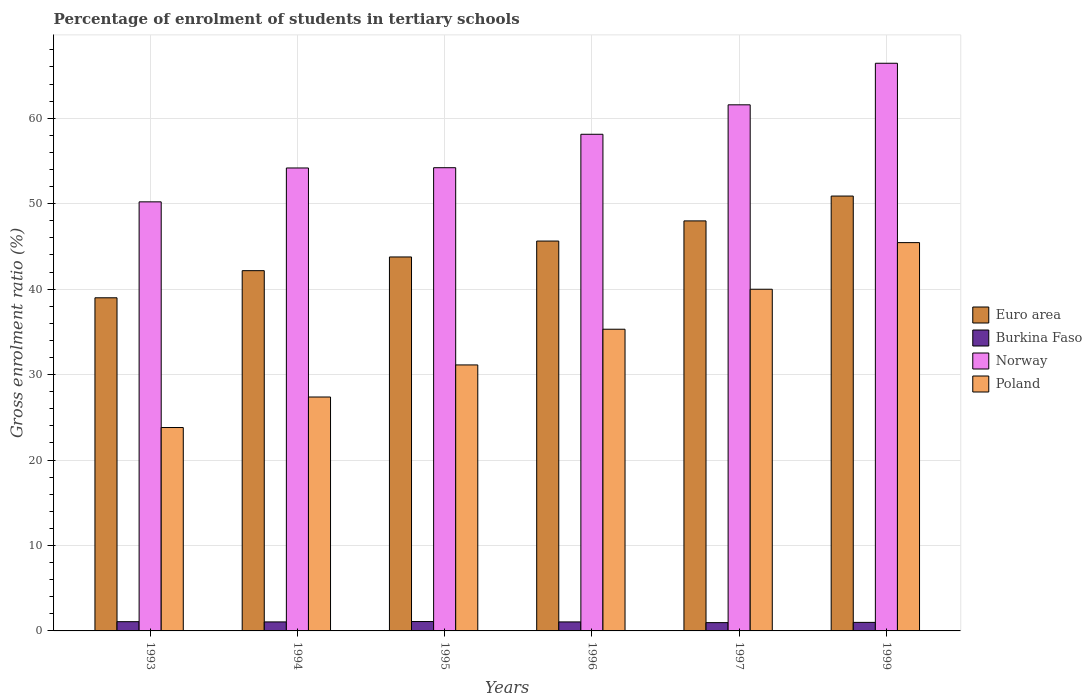Are the number of bars per tick equal to the number of legend labels?
Offer a very short reply. Yes. Are the number of bars on each tick of the X-axis equal?
Ensure brevity in your answer.  Yes. How many bars are there on the 3rd tick from the right?
Make the answer very short. 4. What is the label of the 3rd group of bars from the left?
Your response must be concise. 1995. What is the percentage of students enrolled in tertiary schools in Poland in 1995?
Your answer should be very brief. 31.13. Across all years, what is the maximum percentage of students enrolled in tertiary schools in Euro area?
Keep it short and to the point. 50.89. Across all years, what is the minimum percentage of students enrolled in tertiary schools in Norway?
Your response must be concise. 50.21. What is the total percentage of students enrolled in tertiary schools in Norway in the graph?
Give a very brief answer. 344.69. What is the difference between the percentage of students enrolled in tertiary schools in Euro area in 1997 and that in 1999?
Provide a succinct answer. -2.91. What is the difference between the percentage of students enrolled in tertiary schools in Burkina Faso in 1993 and the percentage of students enrolled in tertiary schools in Poland in 1995?
Give a very brief answer. -30.04. What is the average percentage of students enrolled in tertiary schools in Poland per year?
Offer a very short reply. 33.84. In the year 1996, what is the difference between the percentage of students enrolled in tertiary schools in Poland and percentage of students enrolled in tertiary schools in Burkina Faso?
Your answer should be very brief. 34.25. What is the ratio of the percentage of students enrolled in tertiary schools in Poland in 1994 to that in 1995?
Your response must be concise. 0.88. Is the percentage of students enrolled in tertiary schools in Norway in 1996 less than that in 1997?
Keep it short and to the point. Yes. Is the difference between the percentage of students enrolled in tertiary schools in Poland in 1994 and 1997 greater than the difference between the percentage of students enrolled in tertiary schools in Burkina Faso in 1994 and 1997?
Your answer should be very brief. No. What is the difference between the highest and the second highest percentage of students enrolled in tertiary schools in Burkina Faso?
Make the answer very short. 0.02. What is the difference between the highest and the lowest percentage of students enrolled in tertiary schools in Poland?
Your answer should be very brief. 21.64. Is it the case that in every year, the sum of the percentage of students enrolled in tertiary schools in Burkina Faso and percentage of students enrolled in tertiary schools in Norway is greater than the sum of percentage of students enrolled in tertiary schools in Poland and percentage of students enrolled in tertiary schools in Euro area?
Your answer should be very brief. Yes. What does the 3rd bar from the left in 1996 represents?
Your answer should be very brief. Norway. How many bars are there?
Your answer should be very brief. 24. Are all the bars in the graph horizontal?
Offer a very short reply. No. What is the difference between two consecutive major ticks on the Y-axis?
Your response must be concise. 10. Are the values on the major ticks of Y-axis written in scientific E-notation?
Provide a short and direct response. No. Does the graph contain grids?
Provide a short and direct response. Yes. Where does the legend appear in the graph?
Ensure brevity in your answer.  Center right. How are the legend labels stacked?
Offer a terse response. Vertical. What is the title of the graph?
Your response must be concise. Percentage of enrolment of students in tertiary schools. Does "Albania" appear as one of the legend labels in the graph?
Provide a succinct answer. No. What is the label or title of the Y-axis?
Your answer should be compact. Gross enrolment ratio (%). What is the Gross enrolment ratio (%) in Euro area in 1993?
Ensure brevity in your answer.  38.98. What is the Gross enrolment ratio (%) in Burkina Faso in 1993?
Offer a terse response. 1.08. What is the Gross enrolment ratio (%) in Norway in 1993?
Your answer should be very brief. 50.21. What is the Gross enrolment ratio (%) of Poland in 1993?
Your answer should be compact. 23.8. What is the Gross enrolment ratio (%) in Euro area in 1994?
Your response must be concise. 42.16. What is the Gross enrolment ratio (%) of Burkina Faso in 1994?
Offer a very short reply. 1.05. What is the Gross enrolment ratio (%) of Norway in 1994?
Keep it short and to the point. 54.17. What is the Gross enrolment ratio (%) of Poland in 1994?
Make the answer very short. 27.37. What is the Gross enrolment ratio (%) in Euro area in 1995?
Your response must be concise. 43.76. What is the Gross enrolment ratio (%) in Burkina Faso in 1995?
Make the answer very short. 1.1. What is the Gross enrolment ratio (%) of Norway in 1995?
Offer a very short reply. 54.2. What is the Gross enrolment ratio (%) of Poland in 1995?
Make the answer very short. 31.13. What is the Gross enrolment ratio (%) of Euro area in 1996?
Your answer should be very brief. 45.62. What is the Gross enrolment ratio (%) of Burkina Faso in 1996?
Offer a terse response. 1.05. What is the Gross enrolment ratio (%) in Norway in 1996?
Ensure brevity in your answer.  58.12. What is the Gross enrolment ratio (%) in Poland in 1996?
Your answer should be very brief. 35.3. What is the Gross enrolment ratio (%) in Euro area in 1997?
Your response must be concise. 47.98. What is the Gross enrolment ratio (%) in Burkina Faso in 1997?
Your answer should be compact. 0.97. What is the Gross enrolment ratio (%) of Norway in 1997?
Your answer should be very brief. 61.56. What is the Gross enrolment ratio (%) in Poland in 1997?
Offer a very short reply. 39.98. What is the Gross enrolment ratio (%) of Euro area in 1999?
Offer a very short reply. 50.89. What is the Gross enrolment ratio (%) of Burkina Faso in 1999?
Make the answer very short. 1. What is the Gross enrolment ratio (%) in Norway in 1999?
Your answer should be very brief. 66.43. What is the Gross enrolment ratio (%) in Poland in 1999?
Your answer should be compact. 45.44. Across all years, what is the maximum Gross enrolment ratio (%) in Euro area?
Your answer should be very brief. 50.89. Across all years, what is the maximum Gross enrolment ratio (%) in Burkina Faso?
Ensure brevity in your answer.  1.1. Across all years, what is the maximum Gross enrolment ratio (%) of Norway?
Your response must be concise. 66.43. Across all years, what is the maximum Gross enrolment ratio (%) of Poland?
Provide a succinct answer. 45.44. Across all years, what is the minimum Gross enrolment ratio (%) of Euro area?
Provide a succinct answer. 38.98. Across all years, what is the minimum Gross enrolment ratio (%) of Burkina Faso?
Ensure brevity in your answer.  0.97. Across all years, what is the minimum Gross enrolment ratio (%) in Norway?
Your answer should be very brief. 50.21. Across all years, what is the minimum Gross enrolment ratio (%) in Poland?
Make the answer very short. 23.8. What is the total Gross enrolment ratio (%) in Euro area in the graph?
Your response must be concise. 269.39. What is the total Gross enrolment ratio (%) in Burkina Faso in the graph?
Keep it short and to the point. 6.26. What is the total Gross enrolment ratio (%) in Norway in the graph?
Offer a terse response. 344.69. What is the total Gross enrolment ratio (%) in Poland in the graph?
Keep it short and to the point. 203.02. What is the difference between the Gross enrolment ratio (%) in Euro area in 1993 and that in 1994?
Provide a succinct answer. -3.17. What is the difference between the Gross enrolment ratio (%) in Burkina Faso in 1993 and that in 1994?
Give a very brief answer. 0.03. What is the difference between the Gross enrolment ratio (%) in Norway in 1993 and that in 1994?
Provide a succinct answer. -3.96. What is the difference between the Gross enrolment ratio (%) in Poland in 1993 and that in 1994?
Give a very brief answer. -3.57. What is the difference between the Gross enrolment ratio (%) in Euro area in 1993 and that in 1995?
Provide a succinct answer. -4.78. What is the difference between the Gross enrolment ratio (%) of Burkina Faso in 1993 and that in 1995?
Offer a terse response. -0.02. What is the difference between the Gross enrolment ratio (%) in Norway in 1993 and that in 1995?
Provide a short and direct response. -4. What is the difference between the Gross enrolment ratio (%) in Poland in 1993 and that in 1995?
Your answer should be compact. -7.32. What is the difference between the Gross enrolment ratio (%) in Euro area in 1993 and that in 1996?
Offer a terse response. -6.64. What is the difference between the Gross enrolment ratio (%) in Burkina Faso in 1993 and that in 1996?
Your answer should be compact. 0.03. What is the difference between the Gross enrolment ratio (%) in Norway in 1993 and that in 1996?
Ensure brevity in your answer.  -7.91. What is the difference between the Gross enrolment ratio (%) in Poland in 1993 and that in 1996?
Your response must be concise. -11.5. What is the difference between the Gross enrolment ratio (%) in Euro area in 1993 and that in 1997?
Offer a very short reply. -9. What is the difference between the Gross enrolment ratio (%) of Burkina Faso in 1993 and that in 1997?
Make the answer very short. 0.11. What is the difference between the Gross enrolment ratio (%) in Norway in 1993 and that in 1997?
Your answer should be compact. -11.36. What is the difference between the Gross enrolment ratio (%) of Poland in 1993 and that in 1997?
Your response must be concise. -16.18. What is the difference between the Gross enrolment ratio (%) in Euro area in 1993 and that in 1999?
Give a very brief answer. -11.9. What is the difference between the Gross enrolment ratio (%) in Burkina Faso in 1993 and that in 1999?
Provide a short and direct response. 0.08. What is the difference between the Gross enrolment ratio (%) of Norway in 1993 and that in 1999?
Give a very brief answer. -16.22. What is the difference between the Gross enrolment ratio (%) in Poland in 1993 and that in 1999?
Ensure brevity in your answer.  -21.64. What is the difference between the Gross enrolment ratio (%) of Euro area in 1994 and that in 1995?
Offer a very short reply. -1.6. What is the difference between the Gross enrolment ratio (%) of Burkina Faso in 1994 and that in 1995?
Your response must be concise. -0.04. What is the difference between the Gross enrolment ratio (%) of Norway in 1994 and that in 1995?
Give a very brief answer. -0.03. What is the difference between the Gross enrolment ratio (%) in Poland in 1994 and that in 1995?
Your answer should be very brief. -3.75. What is the difference between the Gross enrolment ratio (%) of Euro area in 1994 and that in 1996?
Provide a short and direct response. -3.46. What is the difference between the Gross enrolment ratio (%) in Norway in 1994 and that in 1996?
Make the answer very short. -3.94. What is the difference between the Gross enrolment ratio (%) of Poland in 1994 and that in 1996?
Offer a terse response. -7.93. What is the difference between the Gross enrolment ratio (%) of Euro area in 1994 and that in 1997?
Keep it short and to the point. -5.82. What is the difference between the Gross enrolment ratio (%) of Burkina Faso in 1994 and that in 1997?
Provide a short and direct response. 0.09. What is the difference between the Gross enrolment ratio (%) in Norway in 1994 and that in 1997?
Keep it short and to the point. -7.39. What is the difference between the Gross enrolment ratio (%) of Poland in 1994 and that in 1997?
Keep it short and to the point. -12.61. What is the difference between the Gross enrolment ratio (%) in Euro area in 1994 and that in 1999?
Provide a short and direct response. -8.73. What is the difference between the Gross enrolment ratio (%) in Burkina Faso in 1994 and that in 1999?
Ensure brevity in your answer.  0.06. What is the difference between the Gross enrolment ratio (%) in Norway in 1994 and that in 1999?
Give a very brief answer. -12.25. What is the difference between the Gross enrolment ratio (%) in Poland in 1994 and that in 1999?
Your answer should be compact. -18.07. What is the difference between the Gross enrolment ratio (%) of Euro area in 1995 and that in 1996?
Offer a very short reply. -1.86. What is the difference between the Gross enrolment ratio (%) of Burkina Faso in 1995 and that in 1996?
Provide a succinct answer. 0.04. What is the difference between the Gross enrolment ratio (%) of Norway in 1995 and that in 1996?
Your response must be concise. -3.91. What is the difference between the Gross enrolment ratio (%) in Poland in 1995 and that in 1996?
Provide a succinct answer. -4.18. What is the difference between the Gross enrolment ratio (%) of Euro area in 1995 and that in 1997?
Give a very brief answer. -4.22. What is the difference between the Gross enrolment ratio (%) in Burkina Faso in 1995 and that in 1997?
Keep it short and to the point. 0.13. What is the difference between the Gross enrolment ratio (%) of Norway in 1995 and that in 1997?
Keep it short and to the point. -7.36. What is the difference between the Gross enrolment ratio (%) in Poland in 1995 and that in 1997?
Ensure brevity in your answer.  -8.86. What is the difference between the Gross enrolment ratio (%) in Euro area in 1995 and that in 1999?
Provide a succinct answer. -7.13. What is the difference between the Gross enrolment ratio (%) in Burkina Faso in 1995 and that in 1999?
Offer a terse response. 0.1. What is the difference between the Gross enrolment ratio (%) in Norway in 1995 and that in 1999?
Keep it short and to the point. -12.22. What is the difference between the Gross enrolment ratio (%) of Poland in 1995 and that in 1999?
Your answer should be compact. -14.31. What is the difference between the Gross enrolment ratio (%) in Euro area in 1996 and that in 1997?
Provide a short and direct response. -2.36. What is the difference between the Gross enrolment ratio (%) in Burkina Faso in 1996 and that in 1997?
Offer a terse response. 0.09. What is the difference between the Gross enrolment ratio (%) of Norway in 1996 and that in 1997?
Offer a very short reply. -3.45. What is the difference between the Gross enrolment ratio (%) of Poland in 1996 and that in 1997?
Offer a very short reply. -4.68. What is the difference between the Gross enrolment ratio (%) in Euro area in 1996 and that in 1999?
Your answer should be very brief. -5.27. What is the difference between the Gross enrolment ratio (%) in Burkina Faso in 1996 and that in 1999?
Provide a succinct answer. 0.06. What is the difference between the Gross enrolment ratio (%) in Norway in 1996 and that in 1999?
Ensure brevity in your answer.  -8.31. What is the difference between the Gross enrolment ratio (%) of Poland in 1996 and that in 1999?
Your answer should be compact. -10.13. What is the difference between the Gross enrolment ratio (%) of Euro area in 1997 and that in 1999?
Ensure brevity in your answer.  -2.91. What is the difference between the Gross enrolment ratio (%) of Burkina Faso in 1997 and that in 1999?
Provide a succinct answer. -0.03. What is the difference between the Gross enrolment ratio (%) in Norway in 1997 and that in 1999?
Offer a very short reply. -4.86. What is the difference between the Gross enrolment ratio (%) in Poland in 1997 and that in 1999?
Offer a terse response. -5.46. What is the difference between the Gross enrolment ratio (%) of Euro area in 1993 and the Gross enrolment ratio (%) of Burkina Faso in 1994?
Your answer should be compact. 37.93. What is the difference between the Gross enrolment ratio (%) in Euro area in 1993 and the Gross enrolment ratio (%) in Norway in 1994?
Your response must be concise. -15.19. What is the difference between the Gross enrolment ratio (%) in Euro area in 1993 and the Gross enrolment ratio (%) in Poland in 1994?
Your answer should be compact. 11.61. What is the difference between the Gross enrolment ratio (%) in Burkina Faso in 1993 and the Gross enrolment ratio (%) in Norway in 1994?
Your answer should be compact. -53.09. What is the difference between the Gross enrolment ratio (%) in Burkina Faso in 1993 and the Gross enrolment ratio (%) in Poland in 1994?
Your answer should be compact. -26.29. What is the difference between the Gross enrolment ratio (%) in Norway in 1993 and the Gross enrolment ratio (%) in Poland in 1994?
Keep it short and to the point. 22.84. What is the difference between the Gross enrolment ratio (%) of Euro area in 1993 and the Gross enrolment ratio (%) of Burkina Faso in 1995?
Your answer should be compact. 37.88. What is the difference between the Gross enrolment ratio (%) of Euro area in 1993 and the Gross enrolment ratio (%) of Norway in 1995?
Offer a very short reply. -15.22. What is the difference between the Gross enrolment ratio (%) of Euro area in 1993 and the Gross enrolment ratio (%) of Poland in 1995?
Ensure brevity in your answer.  7.86. What is the difference between the Gross enrolment ratio (%) of Burkina Faso in 1993 and the Gross enrolment ratio (%) of Norway in 1995?
Your response must be concise. -53.12. What is the difference between the Gross enrolment ratio (%) of Burkina Faso in 1993 and the Gross enrolment ratio (%) of Poland in 1995?
Keep it short and to the point. -30.04. What is the difference between the Gross enrolment ratio (%) of Norway in 1993 and the Gross enrolment ratio (%) of Poland in 1995?
Provide a succinct answer. 19.08. What is the difference between the Gross enrolment ratio (%) in Euro area in 1993 and the Gross enrolment ratio (%) in Burkina Faso in 1996?
Give a very brief answer. 37.93. What is the difference between the Gross enrolment ratio (%) in Euro area in 1993 and the Gross enrolment ratio (%) in Norway in 1996?
Offer a terse response. -19.13. What is the difference between the Gross enrolment ratio (%) of Euro area in 1993 and the Gross enrolment ratio (%) of Poland in 1996?
Ensure brevity in your answer.  3.68. What is the difference between the Gross enrolment ratio (%) of Burkina Faso in 1993 and the Gross enrolment ratio (%) of Norway in 1996?
Provide a succinct answer. -57.04. What is the difference between the Gross enrolment ratio (%) in Burkina Faso in 1993 and the Gross enrolment ratio (%) in Poland in 1996?
Give a very brief answer. -34.22. What is the difference between the Gross enrolment ratio (%) of Norway in 1993 and the Gross enrolment ratio (%) of Poland in 1996?
Keep it short and to the point. 14.9. What is the difference between the Gross enrolment ratio (%) of Euro area in 1993 and the Gross enrolment ratio (%) of Burkina Faso in 1997?
Offer a very short reply. 38.01. What is the difference between the Gross enrolment ratio (%) of Euro area in 1993 and the Gross enrolment ratio (%) of Norway in 1997?
Give a very brief answer. -22.58. What is the difference between the Gross enrolment ratio (%) of Euro area in 1993 and the Gross enrolment ratio (%) of Poland in 1997?
Ensure brevity in your answer.  -1. What is the difference between the Gross enrolment ratio (%) of Burkina Faso in 1993 and the Gross enrolment ratio (%) of Norway in 1997?
Offer a very short reply. -60.48. What is the difference between the Gross enrolment ratio (%) in Burkina Faso in 1993 and the Gross enrolment ratio (%) in Poland in 1997?
Keep it short and to the point. -38.9. What is the difference between the Gross enrolment ratio (%) of Norway in 1993 and the Gross enrolment ratio (%) of Poland in 1997?
Make the answer very short. 10.23. What is the difference between the Gross enrolment ratio (%) of Euro area in 1993 and the Gross enrolment ratio (%) of Burkina Faso in 1999?
Your response must be concise. 37.98. What is the difference between the Gross enrolment ratio (%) of Euro area in 1993 and the Gross enrolment ratio (%) of Norway in 1999?
Provide a short and direct response. -27.45. What is the difference between the Gross enrolment ratio (%) in Euro area in 1993 and the Gross enrolment ratio (%) in Poland in 1999?
Provide a short and direct response. -6.46. What is the difference between the Gross enrolment ratio (%) of Burkina Faso in 1993 and the Gross enrolment ratio (%) of Norway in 1999?
Your answer should be compact. -65.35. What is the difference between the Gross enrolment ratio (%) of Burkina Faso in 1993 and the Gross enrolment ratio (%) of Poland in 1999?
Give a very brief answer. -44.36. What is the difference between the Gross enrolment ratio (%) in Norway in 1993 and the Gross enrolment ratio (%) in Poland in 1999?
Provide a succinct answer. 4.77. What is the difference between the Gross enrolment ratio (%) of Euro area in 1994 and the Gross enrolment ratio (%) of Burkina Faso in 1995?
Make the answer very short. 41.06. What is the difference between the Gross enrolment ratio (%) of Euro area in 1994 and the Gross enrolment ratio (%) of Norway in 1995?
Your answer should be very brief. -12.05. What is the difference between the Gross enrolment ratio (%) in Euro area in 1994 and the Gross enrolment ratio (%) in Poland in 1995?
Make the answer very short. 11.03. What is the difference between the Gross enrolment ratio (%) of Burkina Faso in 1994 and the Gross enrolment ratio (%) of Norway in 1995?
Keep it short and to the point. -53.15. What is the difference between the Gross enrolment ratio (%) in Burkina Faso in 1994 and the Gross enrolment ratio (%) in Poland in 1995?
Offer a very short reply. -30.07. What is the difference between the Gross enrolment ratio (%) in Norway in 1994 and the Gross enrolment ratio (%) in Poland in 1995?
Give a very brief answer. 23.05. What is the difference between the Gross enrolment ratio (%) of Euro area in 1994 and the Gross enrolment ratio (%) of Burkina Faso in 1996?
Give a very brief answer. 41.1. What is the difference between the Gross enrolment ratio (%) of Euro area in 1994 and the Gross enrolment ratio (%) of Norway in 1996?
Offer a very short reply. -15.96. What is the difference between the Gross enrolment ratio (%) of Euro area in 1994 and the Gross enrolment ratio (%) of Poland in 1996?
Offer a terse response. 6.85. What is the difference between the Gross enrolment ratio (%) in Burkina Faso in 1994 and the Gross enrolment ratio (%) in Norway in 1996?
Your answer should be compact. -57.06. What is the difference between the Gross enrolment ratio (%) of Burkina Faso in 1994 and the Gross enrolment ratio (%) of Poland in 1996?
Offer a very short reply. -34.25. What is the difference between the Gross enrolment ratio (%) of Norway in 1994 and the Gross enrolment ratio (%) of Poland in 1996?
Offer a very short reply. 18.87. What is the difference between the Gross enrolment ratio (%) of Euro area in 1994 and the Gross enrolment ratio (%) of Burkina Faso in 1997?
Provide a short and direct response. 41.19. What is the difference between the Gross enrolment ratio (%) in Euro area in 1994 and the Gross enrolment ratio (%) in Norway in 1997?
Ensure brevity in your answer.  -19.41. What is the difference between the Gross enrolment ratio (%) of Euro area in 1994 and the Gross enrolment ratio (%) of Poland in 1997?
Provide a short and direct response. 2.17. What is the difference between the Gross enrolment ratio (%) of Burkina Faso in 1994 and the Gross enrolment ratio (%) of Norway in 1997?
Make the answer very short. -60.51. What is the difference between the Gross enrolment ratio (%) in Burkina Faso in 1994 and the Gross enrolment ratio (%) in Poland in 1997?
Your answer should be very brief. -38.93. What is the difference between the Gross enrolment ratio (%) in Norway in 1994 and the Gross enrolment ratio (%) in Poland in 1997?
Provide a succinct answer. 14.19. What is the difference between the Gross enrolment ratio (%) in Euro area in 1994 and the Gross enrolment ratio (%) in Burkina Faso in 1999?
Give a very brief answer. 41.16. What is the difference between the Gross enrolment ratio (%) in Euro area in 1994 and the Gross enrolment ratio (%) in Norway in 1999?
Your answer should be compact. -24.27. What is the difference between the Gross enrolment ratio (%) of Euro area in 1994 and the Gross enrolment ratio (%) of Poland in 1999?
Your answer should be very brief. -3.28. What is the difference between the Gross enrolment ratio (%) of Burkina Faso in 1994 and the Gross enrolment ratio (%) of Norway in 1999?
Provide a short and direct response. -65.37. What is the difference between the Gross enrolment ratio (%) of Burkina Faso in 1994 and the Gross enrolment ratio (%) of Poland in 1999?
Make the answer very short. -44.38. What is the difference between the Gross enrolment ratio (%) in Norway in 1994 and the Gross enrolment ratio (%) in Poland in 1999?
Keep it short and to the point. 8.73. What is the difference between the Gross enrolment ratio (%) in Euro area in 1995 and the Gross enrolment ratio (%) in Burkina Faso in 1996?
Offer a terse response. 42.71. What is the difference between the Gross enrolment ratio (%) in Euro area in 1995 and the Gross enrolment ratio (%) in Norway in 1996?
Ensure brevity in your answer.  -14.36. What is the difference between the Gross enrolment ratio (%) of Euro area in 1995 and the Gross enrolment ratio (%) of Poland in 1996?
Keep it short and to the point. 8.46. What is the difference between the Gross enrolment ratio (%) of Burkina Faso in 1995 and the Gross enrolment ratio (%) of Norway in 1996?
Provide a short and direct response. -57.02. What is the difference between the Gross enrolment ratio (%) of Burkina Faso in 1995 and the Gross enrolment ratio (%) of Poland in 1996?
Make the answer very short. -34.21. What is the difference between the Gross enrolment ratio (%) in Norway in 1995 and the Gross enrolment ratio (%) in Poland in 1996?
Offer a terse response. 18.9. What is the difference between the Gross enrolment ratio (%) in Euro area in 1995 and the Gross enrolment ratio (%) in Burkina Faso in 1997?
Give a very brief answer. 42.79. What is the difference between the Gross enrolment ratio (%) in Euro area in 1995 and the Gross enrolment ratio (%) in Norway in 1997?
Give a very brief answer. -17.8. What is the difference between the Gross enrolment ratio (%) in Euro area in 1995 and the Gross enrolment ratio (%) in Poland in 1997?
Ensure brevity in your answer.  3.78. What is the difference between the Gross enrolment ratio (%) in Burkina Faso in 1995 and the Gross enrolment ratio (%) in Norway in 1997?
Your answer should be very brief. -60.47. What is the difference between the Gross enrolment ratio (%) in Burkina Faso in 1995 and the Gross enrolment ratio (%) in Poland in 1997?
Your answer should be very brief. -38.89. What is the difference between the Gross enrolment ratio (%) in Norway in 1995 and the Gross enrolment ratio (%) in Poland in 1997?
Ensure brevity in your answer.  14.22. What is the difference between the Gross enrolment ratio (%) in Euro area in 1995 and the Gross enrolment ratio (%) in Burkina Faso in 1999?
Your answer should be compact. 42.76. What is the difference between the Gross enrolment ratio (%) in Euro area in 1995 and the Gross enrolment ratio (%) in Norway in 1999?
Your response must be concise. -22.67. What is the difference between the Gross enrolment ratio (%) in Euro area in 1995 and the Gross enrolment ratio (%) in Poland in 1999?
Make the answer very short. -1.68. What is the difference between the Gross enrolment ratio (%) of Burkina Faso in 1995 and the Gross enrolment ratio (%) of Norway in 1999?
Make the answer very short. -65.33. What is the difference between the Gross enrolment ratio (%) in Burkina Faso in 1995 and the Gross enrolment ratio (%) in Poland in 1999?
Offer a very short reply. -44.34. What is the difference between the Gross enrolment ratio (%) of Norway in 1995 and the Gross enrolment ratio (%) of Poland in 1999?
Ensure brevity in your answer.  8.77. What is the difference between the Gross enrolment ratio (%) of Euro area in 1996 and the Gross enrolment ratio (%) of Burkina Faso in 1997?
Your response must be concise. 44.65. What is the difference between the Gross enrolment ratio (%) of Euro area in 1996 and the Gross enrolment ratio (%) of Norway in 1997?
Offer a very short reply. -15.94. What is the difference between the Gross enrolment ratio (%) of Euro area in 1996 and the Gross enrolment ratio (%) of Poland in 1997?
Give a very brief answer. 5.64. What is the difference between the Gross enrolment ratio (%) in Burkina Faso in 1996 and the Gross enrolment ratio (%) in Norway in 1997?
Your response must be concise. -60.51. What is the difference between the Gross enrolment ratio (%) of Burkina Faso in 1996 and the Gross enrolment ratio (%) of Poland in 1997?
Give a very brief answer. -38.93. What is the difference between the Gross enrolment ratio (%) of Norway in 1996 and the Gross enrolment ratio (%) of Poland in 1997?
Your response must be concise. 18.13. What is the difference between the Gross enrolment ratio (%) in Euro area in 1996 and the Gross enrolment ratio (%) in Burkina Faso in 1999?
Ensure brevity in your answer.  44.62. What is the difference between the Gross enrolment ratio (%) of Euro area in 1996 and the Gross enrolment ratio (%) of Norway in 1999?
Make the answer very short. -20.81. What is the difference between the Gross enrolment ratio (%) in Euro area in 1996 and the Gross enrolment ratio (%) in Poland in 1999?
Provide a short and direct response. 0.18. What is the difference between the Gross enrolment ratio (%) in Burkina Faso in 1996 and the Gross enrolment ratio (%) in Norway in 1999?
Give a very brief answer. -65.37. What is the difference between the Gross enrolment ratio (%) in Burkina Faso in 1996 and the Gross enrolment ratio (%) in Poland in 1999?
Make the answer very short. -44.38. What is the difference between the Gross enrolment ratio (%) in Norway in 1996 and the Gross enrolment ratio (%) in Poland in 1999?
Keep it short and to the point. 12.68. What is the difference between the Gross enrolment ratio (%) in Euro area in 1997 and the Gross enrolment ratio (%) in Burkina Faso in 1999?
Offer a terse response. 46.98. What is the difference between the Gross enrolment ratio (%) of Euro area in 1997 and the Gross enrolment ratio (%) of Norway in 1999?
Your answer should be compact. -18.45. What is the difference between the Gross enrolment ratio (%) of Euro area in 1997 and the Gross enrolment ratio (%) of Poland in 1999?
Your answer should be compact. 2.54. What is the difference between the Gross enrolment ratio (%) in Burkina Faso in 1997 and the Gross enrolment ratio (%) in Norway in 1999?
Provide a short and direct response. -65.46. What is the difference between the Gross enrolment ratio (%) in Burkina Faso in 1997 and the Gross enrolment ratio (%) in Poland in 1999?
Offer a terse response. -44.47. What is the difference between the Gross enrolment ratio (%) in Norway in 1997 and the Gross enrolment ratio (%) in Poland in 1999?
Offer a very short reply. 16.13. What is the average Gross enrolment ratio (%) of Euro area per year?
Give a very brief answer. 44.9. What is the average Gross enrolment ratio (%) of Burkina Faso per year?
Your answer should be very brief. 1.04. What is the average Gross enrolment ratio (%) in Norway per year?
Provide a short and direct response. 57.45. What is the average Gross enrolment ratio (%) in Poland per year?
Offer a terse response. 33.84. In the year 1993, what is the difference between the Gross enrolment ratio (%) of Euro area and Gross enrolment ratio (%) of Burkina Faso?
Your answer should be very brief. 37.9. In the year 1993, what is the difference between the Gross enrolment ratio (%) of Euro area and Gross enrolment ratio (%) of Norway?
Your response must be concise. -11.23. In the year 1993, what is the difference between the Gross enrolment ratio (%) of Euro area and Gross enrolment ratio (%) of Poland?
Offer a terse response. 15.18. In the year 1993, what is the difference between the Gross enrolment ratio (%) of Burkina Faso and Gross enrolment ratio (%) of Norway?
Ensure brevity in your answer.  -49.13. In the year 1993, what is the difference between the Gross enrolment ratio (%) in Burkina Faso and Gross enrolment ratio (%) in Poland?
Offer a very short reply. -22.72. In the year 1993, what is the difference between the Gross enrolment ratio (%) in Norway and Gross enrolment ratio (%) in Poland?
Keep it short and to the point. 26.41. In the year 1994, what is the difference between the Gross enrolment ratio (%) of Euro area and Gross enrolment ratio (%) of Burkina Faso?
Make the answer very short. 41.1. In the year 1994, what is the difference between the Gross enrolment ratio (%) of Euro area and Gross enrolment ratio (%) of Norway?
Your response must be concise. -12.02. In the year 1994, what is the difference between the Gross enrolment ratio (%) of Euro area and Gross enrolment ratio (%) of Poland?
Your answer should be compact. 14.79. In the year 1994, what is the difference between the Gross enrolment ratio (%) of Burkina Faso and Gross enrolment ratio (%) of Norway?
Offer a terse response. -53.12. In the year 1994, what is the difference between the Gross enrolment ratio (%) of Burkina Faso and Gross enrolment ratio (%) of Poland?
Ensure brevity in your answer.  -26.32. In the year 1994, what is the difference between the Gross enrolment ratio (%) in Norway and Gross enrolment ratio (%) in Poland?
Offer a very short reply. 26.8. In the year 1995, what is the difference between the Gross enrolment ratio (%) in Euro area and Gross enrolment ratio (%) in Burkina Faso?
Your response must be concise. 42.66. In the year 1995, what is the difference between the Gross enrolment ratio (%) of Euro area and Gross enrolment ratio (%) of Norway?
Your answer should be very brief. -10.44. In the year 1995, what is the difference between the Gross enrolment ratio (%) of Euro area and Gross enrolment ratio (%) of Poland?
Make the answer very short. 12.64. In the year 1995, what is the difference between the Gross enrolment ratio (%) in Burkina Faso and Gross enrolment ratio (%) in Norway?
Ensure brevity in your answer.  -53.11. In the year 1995, what is the difference between the Gross enrolment ratio (%) in Burkina Faso and Gross enrolment ratio (%) in Poland?
Make the answer very short. -30.03. In the year 1995, what is the difference between the Gross enrolment ratio (%) in Norway and Gross enrolment ratio (%) in Poland?
Your answer should be very brief. 23.08. In the year 1996, what is the difference between the Gross enrolment ratio (%) of Euro area and Gross enrolment ratio (%) of Burkina Faso?
Ensure brevity in your answer.  44.57. In the year 1996, what is the difference between the Gross enrolment ratio (%) in Euro area and Gross enrolment ratio (%) in Norway?
Your answer should be very brief. -12.5. In the year 1996, what is the difference between the Gross enrolment ratio (%) in Euro area and Gross enrolment ratio (%) in Poland?
Your answer should be very brief. 10.32. In the year 1996, what is the difference between the Gross enrolment ratio (%) of Burkina Faso and Gross enrolment ratio (%) of Norway?
Your response must be concise. -57.06. In the year 1996, what is the difference between the Gross enrolment ratio (%) of Burkina Faso and Gross enrolment ratio (%) of Poland?
Provide a succinct answer. -34.25. In the year 1996, what is the difference between the Gross enrolment ratio (%) of Norway and Gross enrolment ratio (%) of Poland?
Offer a very short reply. 22.81. In the year 1997, what is the difference between the Gross enrolment ratio (%) of Euro area and Gross enrolment ratio (%) of Burkina Faso?
Offer a very short reply. 47.01. In the year 1997, what is the difference between the Gross enrolment ratio (%) of Euro area and Gross enrolment ratio (%) of Norway?
Provide a short and direct response. -13.58. In the year 1997, what is the difference between the Gross enrolment ratio (%) of Euro area and Gross enrolment ratio (%) of Poland?
Provide a succinct answer. 8. In the year 1997, what is the difference between the Gross enrolment ratio (%) of Burkina Faso and Gross enrolment ratio (%) of Norway?
Ensure brevity in your answer.  -60.6. In the year 1997, what is the difference between the Gross enrolment ratio (%) of Burkina Faso and Gross enrolment ratio (%) of Poland?
Make the answer very short. -39.01. In the year 1997, what is the difference between the Gross enrolment ratio (%) in Norway and Gross enrolment ratio (%) in Poland?
Provide a succinct answer. 21.58. In the year 1999, what is the difference between the Gross enrolment ratio (%) in Euro area and Gross enrolment ratio (%) in Burkina Faso?
Offer a very short reply. 49.89. In the year 1999, what is the difference between the Gross enrolment ratio (%) in Euro area and Gross enrolment ratio (%) in Norway?
Ensure brevity in your answer.  -15.54. In the year 1999, what is the difference between the Gross enrolment ratio (%) of Euro area and Gross enrolment ratio (%) of Poland?
Your response must be concise. 5.45. In the year 1999, what is the difference between the Gross enrolment ratio (%) in Burkina Faso and Gross enrolment ratio (%) in Norway?
Keep it short and to the point. -65.43. In the year 1999, what is the difference between the Gross enrolment ratio (%) in Burkina Faso and Gross enrolment ratio (%) in Poland?
Offer a terse response. -44.44. In the year 1999, what is the difference between the Gross enrolment ratio (%) of Norway and Gross enrolment ratio (%) of Poland?
Offer a terse response. 20.99. What is the ratio of the Gross enrolment ratio (%) of Euro area in 1993 to that in 1994?
Provide a succinct answer. 0.92. What is the ratio of the Gross enrolment ratio (%) of Burkina Faso in 1993 to that in 1994?
Provide a short and direct response. 1.03. What is the ratio of the Gross enrolment ratio (%) in Norway in 1993 to that in 1994?
Provide a short and direct response. 0.93. What is the ratio of the Gross enrolment ratio (%) in Poland in 1993 to that in 1994?
Offer a terse response. 0.87. What is the ratio of the Gross enrolment ratio (%) of Euro area in 1993 to that in 1995?
Keep it short and to the point. 0.89. What is the ratio of the Gross enrolment ratio (%) of Burkina Faso in 1993 to that in 1995?
Your answer should be very brief. 0.99. What is the ratio of the Gross enrolment ratio (%) in Norway in 1993 to that in 1995?
Your response must be concise. 0.93. What is the ratio of the Gross enrolment ratio (%) of Poland in 1993 to that in 1995?
Provide a short and direct response. 0.76. What is the ratio of the Gross enrolment ratio (%) of Euro area in 1993 to that in 1996?
Offer a terse response. 0.85. What is the ratio of the Gross enrolment ratio (%) in Burkina Faso in 1993 to that in 1996?
Your answer should be compact. 1.03. What is the ratio of the Gross enrolment ratio (%) in Norway in 1993 to that in 1996?
Keep it short and to the point. 0.86. What is the ratio of the Gross enrolment ratio (%) in Poland in 1993 to that in 1996?
Offer a terse response. 0.67. What is the ratio of the Gross enrolment ratio (%) in Euro area in 1993 to that in 1997?
Your answer should be very brief. 0.81. What is the ratio of the Gross enrolment ratio (%) of Burkina Faso in 1993 to that in 1997?
Give a very brief answer. 1.12. What is the ratio of the Gross enrolment ratio (%) in Norway in 1993 to that in 1997?
Provide a short and direct response. 0.82. What is the ratio of the Gross enrolment ratio (%) of Poland in 1993 to that in 1997?
Keep it short and to the point. 0.6. What is the ratio of the Gross enrolment ratio (%) of Euro area in 1993 to that in 1999?
Give a very brief answer. 0.77. What is the ratio of the Gross enrolment ratio (%) in Burkina Faso in 1993 to that in 1999?
Your answer should be very brief. 1.08. What is the ratio of the Gross enrolment ratio (%) of Norway in 1993 to that in 1999?
Your response must be concise. 0.76. What is the ratio of the Gross enrolment ratio (%) in Poland in 1993 to that in 1999?
Offer a very short reply. 0.52. What is the ratio of the Gross enrolment ratio (%) in Euro area in 1994 to that in 1995?
Your answer should be compact. 0.96. What is the ratio of the Gross enrolment ratio (%) in Burkina Faso in 1994 to that in 1995?
Your answer should be very brief. 0.96. What is the ratio of the Gross enrolment ratio (%) of Poland in 1994 to that in 1995?
Ensure brevity in your answer.  0.88. What is the ratio of the Gross enrolment ratio (%) in Euro area in 1994 to that in 1996?
Your answer should be very brief. 0.92. What is the ratio of the Gross enrolment ratio (%) in Norway in 1994 to that in 1996?
Your answer should be compact. 0.93. What is the ratio of the Gross enrolment ratio (%) of Poland in 1994 to that in 1996?
Offer a very short reply. 0.78. What is the ratio of the Gross enrolment ratio (%) of Euro area in 1994 to that in 1997?
Keep it short and to the point. 0.88. What is the ratio of the Gross enrolment ratio (%) in Burkina Faso in 1994 to that in 1997?
Keep it short and to the point. 1.09. What is the ratio of the Gross enrolment ratio (%) in Norway in 1994 to that in 1997?
Offer a terse response. 0.88. What is the ratio of the Gross enrolment ratio (%) of Poland in 1994 to that in 1997?
Offer a very short reply. 0.68. What is the ratio of the Gross enrolment ratio (%) of Euro area in 1994 to that in 1999?
Give a very brief answer. 0.83. What is the ratio of the Gross enrolment ratio (%) in Burkina Faso in 1994 to that in 1999?
Make the answer very short. 1.06. What is the ratio of the Gross enrolment ratio (%) in Norway in 1994 to that in 1999?
Give a very brief answer. 0.82. What is the ratio of the Gross enrolment ratio (%) of Poland in 1994 to that in 1999?
Provide a short and direct response. 0.6. What is the ratio of the Gross enrolment ratio (%) in Euro area in 1995 to that in 1996?
Make the answer very short. 0.96. What is the ratio of the Gross enrolment ratio (%) of Burkina Faso in 1995 to that in 1996?
Keep it short and to the point. 1.04. What is the ratio of the Gross enrolment ratio (%) of Norway in 1995 to that in 1996?
Provide a short and direct response. 0.93. What is the ratio of the Gross enrolment ratio (%) in Poland in 1995 to that in 1996?
Your answer should be very brief. 0.88. What is the ratio of the Gross enrolment ratio (%) in Euro area in 1995 to that in 1997?
Offer a very short reply. 0.91. What is the ratio of the Gross enrolment ratio (%) of Burkina Faso in 1995 to that in 1997?
Ensure brevity in your answer.  1.13. What is the ratio of the Gross enrolment ratio (%) of Norway in 1995 to that in 1997?
Make the answer very short. 0.88. What is the ratio of the Gross enrolment ratio (%) in Poland in 1995 to that in 1997?
Make the answer very short. 0.78. What is the ratio of the Gross enrolment ratio (%) of Euro area in 1995 to that in 1999?
Your response must be concise. 0.86. What is the ratio of the Gross enrolment ratio (%) in Burkina Faso in 1995 to that in 1999?
Ensure brevity in your answer.  1.1. What is the ratio of the Gross enrolment ratio (%) of Norway in 1995 to that in 1999?
Provide a short and direct response. 0.82. What is the ratio of the Gross enrolment ratio (%) in Poland in 1995 to that in 1999?
Provide a succinct answer. 0.69. What is the ratio of the Gross enrolment ratio (%) of Euro area in 1996 to that in 1997?
Provide a succinct answer. 0.95. What is the ratio of the Gross enrolment ratio (%) of Burkina Faso in 1996 to that in 1997?
Your answer should be very brief. 1.09. What is the ratio of the Gross enrolment ratio (%) in Norway in 1996 to that in 1997?
Provide a succinct answer. 0.94. What is the ratio of the Gross enrolment ratio (%) of Poland in 1996 to that in 1997?
Provide a succinct answer. 0.88. What is the ratio of the Gross enrolment ratio (%) in Euro area in 1996 to that in 1999?
Offer a terse response. 0.9. What is the ratio of the Gross enrolment ratio (%) of Burkina Faso in 1996 to that in 1999?
Offer a terse response. 1.06. What is the ratio of the Gross enrolment ratio (%) of Norway in 1996 to that in 1999?
Offer a very short reply. 0.87. What is the ratio of the Gross enrolment ratio (%) in Poland in 1996 to that in 1999?
Your response must be concise. 0.78. What is the ratio of the Gross enrolment ratio (%) of Euro area in 1997 to that in 1999?
Keep it short and to the point. 0.94. What is the ratio of the Gross enrolment ratio (%) of Burkina Faso in 1997 to that in 1999?
Make the answer very short. 0.97. What is the ratio of the Gross enrolment ratio (%) of Norway in 1997 to that in 1999?
Offer a terse response. 0.93. What is the ratio of the Gross enrolment ratio (%) in Poland in 1997 to that in 1999?
Your answer should be very brief. 0.88. What is the difference between the highest and the second highest Gross enrolment ratio (%) in Euro area?
Your response must be concise. 2.91. What is the difference between the highest and the second highest Gross enrolment ratio (%) in Burkina Faso?
Your response must be concise. 0.02. What is the difference between the highest and the second highest Gross enrolment ratio (%) in Norway?
Ensure brevity in your answer.  4.86. What is the difference between the highest and the second highest Gross enrolment ratio (%) in Poland?
Ensure brevity in your answer.  5.46. What is the difference between the highest and the lowest Gross enrolment ratio (%) in Euro area?
Your answer should be compact. 11.9. What is the difference between the highest and the lowest Gross enrolment ratio (%) in Burkina Faso?
Your answer should be compact. 0.13. What is the difference between the highest and the lowest Gross enrolment ratio (%) in Norway?
Provide a short and direct response. 16.22. What is the difference between the highest and the lowest Gross enrolment ratio (%) in Poland?
Make the answer very short. 21.64. 